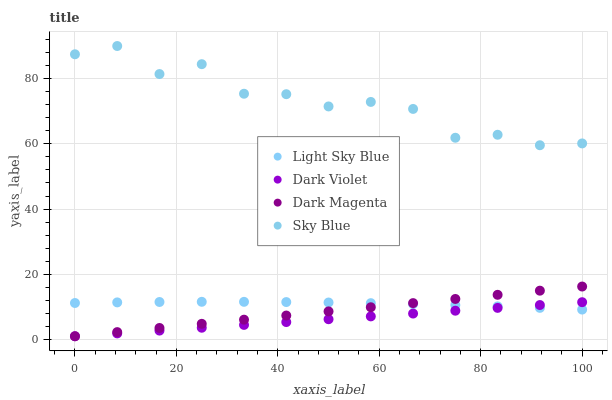Does Dark Violet have the minimum area under the curve?
Answer yes or no. Yes. Does Sky Blue have the maximum area under the curve?
Answer yes or no. Yes. Does Light Sky Blue have the minimum area under the curve?
Answer yes or no. No. Does Light Sky Blue have the maximum area under the curve?
Answer yes or no. No. Is Dark Violet the smoothest?
Answer yes or no. Yes. Is Sky Blue the roughest?
Answer yes or no. Yes. Is Light Sky Blue the smoothest?
Answer yes or no. No. Is Light Sky Blue the roughest?
Answer yes or no. No. Does Dark Magenta have the lowest value?
Answer yes or no. Yes. Does Light Sky Blue have the lowest value?
Answer yes or no. No. Does Sky Blue have the highest value?
Answer yes or no. Yes. Does Light Sky Blue have the highest value?
Answer yes or no. No. Is Dark Violet less than Sky Blue?
Answer yes or no. Yes. Is Sky Blue greater than Light Sky Blue?
Answer yes or no. Yes. Does Light Sky Blue intersect Dark Magenta?
Answer yes or no. Yes. Is Light Sky Blue less than Dark Magenta?
Answer yes or no. No. Is Light Sky Blue greater than Dark Magenta?
Answer yes or no. No. Does Dark Violet intersect Sky Blue?
Answer yes or no. No. 